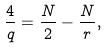<formula> <loc_0><loc_0><loc_500><loc_500>\frac { 4 } { q } = \frac { N } { 2 } - \frac { N } { r } ,</formula> 